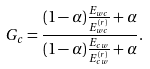<formula> <loc_0><loc_0><loc_500><loc_500>G _ { c } = \frac { ( 1 - \alpha ) \frac { E _ { w c } } { E _ { w c } ^ { ( r ) } } + \alpha } { ( 1 - \alpha ) \frac { E _ { c w } } { E _ { c w } ^ { ( r ) } } + \alpha } .</formula> 